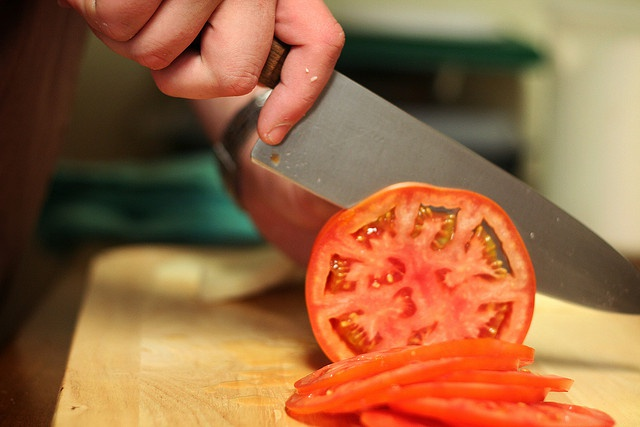Describe the objects in this image and their specific colors. I can see knife in black and gray tones and people in black, salmon, and brown tones in this image. 